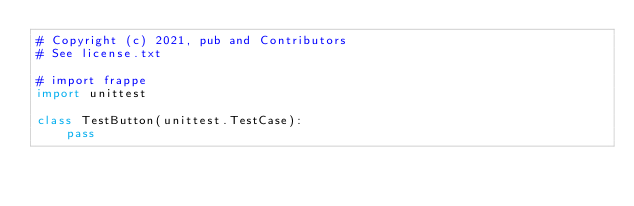<code> <loc_0><loc_0><loc_500><loc_500><_Python_># Copyright (c) 2021, pub and Contributors
# See license.txt

# import frappe
import unittest

class TestButton(unittest.TestCase):
	pass
</code> 